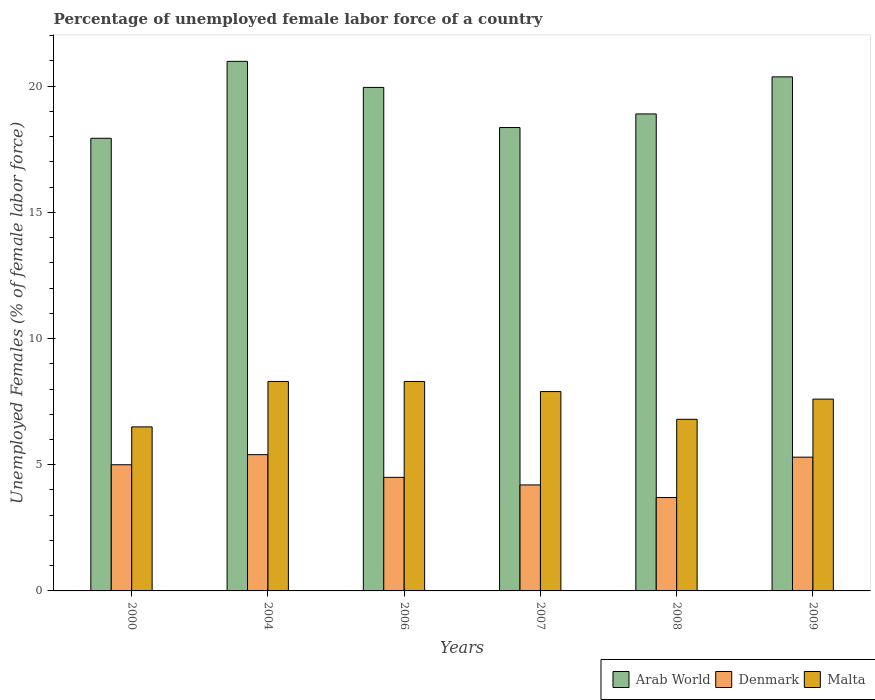How many bars are there on the 1st tick from the left?
Provide a succinct answer. 3. How many bars are there on the 5th tick from the right?
Your answer should be very brief. 3. In how many cases, is the number of bars for a given year not equal to the number of legend labels?
Offer a very short reply. 0. What is the percentage of unemployed female labor force in Denmark in 2008?
Provide a short and direct response. 3.7. Across all years, what is the maximum percentage of unemployed female labor force in Malta?
Your answer should be compact. 8.3. Across all years, what is the minimum percentage of unemployed female labor force in Arab World?
Your response must be concise. 17.94. What is the total percentage of unemployed female labor force in Malta in the graph?
Give a very brief answer. 45.4. What is the difference between the percentage of unemployed female labor force in Malta in 2000 and that in 2006?
Give a very brief answer. -1.8. What is the difference between the percentage of unemployed female labor force in Arab World in 2007 and the percentage of unemployed female labor force in Denmark in 2006?
Provide a succinct answer. 13.86. What is the average percentage of unemployed female labor force in Denmark per year?
Your response must be concise. 4.68. In the year 2006, what is the difference between the percentage of unemployed female labor force in Malta and percentage of unemployed female labor force in Denmark?
Provide a short and direct response. 3.8. What is the ratio of the percentage of unemployed female labor force in Denmark in 2007 to that in 2009?
Offer a very short reply. 0.79. Is the percentage of unemployed female labor force in Denmark in 2000 less than that in 2004?
Offer a terse response. Yes. Is the difference between the percentage of unemployed female labor force in Malta in 2007 and 2008 greater than the difference between the percentage of unemployed female labor force in Denmark in 2007 and 2008?
Make the answer very short. Yes. What is the difference between the highest and the lowest percentage of unemployed female labor force in Denmark?
Your answer should be very brief. 1.7. In how many years, is the percentage of unemployed female labor force in Denmark greater than the average percentage of unemployed female labor force in Denmark taken over all years?
Offer a very short reply. 3. What does the 3rd bar from the left in 2009 represents?
Offer a terse response. Malta. What does the 1st bar from the right in 2007 represents?
Your answer should be very brief. Malta. Is it the case that in every year, the sum of the percentage of unemployed female labor force in Malta and percentage of unemployed female labor force in Denmark is greater than the percentage of unemployed female labor force in Arab World?
Make the answer very short. No. How many bars are there?
Ensure brevity in your answer.  18. Are all the bars in the graph horizontal?
Your response must be concise. No. How many years are there in the graph?
Give a very brief answer. 6. Where does the legend appear in the graph?
Ensure brevity in your answer.  Bottom right. How are the legend labels stacked?
Keep it short and to the point. Horizontal. What is the title of the graph?
Ensure brevity in your answer.  Percentage of unemployed female labor force of a country. What is the label or title of the X-axis?
Your response must be concise. Years. What is the label or title of the Y-axis?
Ensure brevity in your answer.  Unemployed Females (% of female labor force). What is the Unemployed Females (% of female labor force) in Arab World in 2000?
Keep it short and to the point. 17.94. What is the Unemployed Females (% of female labor force) in Denmark in 2000?
Give a very brief answer. 5. What is the Unemployed Females (% of female labor force) in Malta in 2000?
Provide a succinct answer. 6.5. What is the Unemployed Females (% of female labor force) of Arab World in 2004?
Your response must be concise. 20.98. What is the Unemployed Females (% of female labor force) of Denmark in 2004?
Offer a very short reply. 5.4. What is the Unemployed Females (% of female labor force) in Malta in 2004?
Ensure brevity in your answer.  8.3. What is the Unemployed Females (% of female labor force) of Arab World in 2006?
Make the answer very short. 19.95. What is the Unemployed Females (% of female labor force) of Denmark in 2006?
Provide a short and direct response. 4.5. What is the Unemployed Females (% of female labor force) of Malta in 2006?
Your answer should be very brief. 8.3. What is the Unemployed Females (% of female labor force) in Arab World in 2007?
Give a very brief answer. 18.36. What is the Unemployed Females (% of female labor force) of Denmark in 2007?
Your answer should be very brief. 4.2. What is the Unemployed Females (% of female labor force) in Malta in 2007?
Your answer should be very brief. 7.9. What is the Unemployed Females (% of female labor force) of Arab World in 2008?
Make the answer very short. 18.9. What is the Unemployed Females (% of female labor force) in Denmark in 2008?
Your answer should be very brief. 3.7. What is the Unemployed Females (% of female labor force) in Malta in 2008?
Ensure brevity in your answer.  6.8. What is the Unemployed Females (% of female labor force) of Arab World in 2009?
Offer a very short reply. 20.37. What is the Unemployed Females (% of female labor force) of Denmark in 2009?
Provide a succinct answer. 5.3. What is the Unemployed Females (% of female labor force) in Malta in 2009?
Your answer should be very brief. 7.6. Across all years, what is the maximum Unemployed Females (% of female labor force) in Arab World?
Offer a very short reply. 20.98. Across all years, what is the maximum Unemployed Females (% of female labor force) of Denmark?
Give a very brief answer. 5.4. Across all years, what is the maximum Unemployed Females (% of female labor force) in Malta?
Provide a short and direct response. 8.3. Across all years, what is the minimum Unemployed Females (% of female labor force) in Arab World?
Give a very brief answer. 17.94. Across all years, what is the minimum Unemployed Females (% of female labor force) of Denmark?
Offer a very short reply. 3.7. Across all years, what is the minimum Unemployed Females (% of female labor force) of Malta?
Make the answer very short. 6.5. What is the total Unemployed Females (% of female labor force) in Arab World in the graph?
Provide a short and direct response. 116.5. What is the total Unemployed Females (% of female labor force) of Denmark in the graph?
Offer a terse response. 28.1. What is the total Unemployed Females (% of female labor force) in Malta in the graph?
Make the answer very short. 45.4. What is the difference between the Unemployed Females (% of female labor force) of Arab World in 2000 and that in 2004?
Offer a terse response. -3.05. What is the difference between the Unemployed Females (% of female labor force) in Denmark in 2000 and that in 2004?
Offer a terse response. -0.4. What is the difference between the Unemployed Females (% of female labor force) in Malta in 2000 and that in 2004?
Give a very brief answer. -1.8. What is the difference between the Unemployed Females (% of female labor force) in Arab World in 2000 and that in 2006?
Your response must be concise. -2.02. What is the difference between the Unemployed Females (% of female labor force) in Denmark in 2000 and that in 2006?
Make the answer very short. 0.5. What is the difference between the Unemployed Females (% of female labor force) in Arab World in 2000 and that in 2007?
Offer a very short reply. -0.43. What is the difference between the Unemployed Females (% of female labor force) in Denmark in 2000 and that in 2007?
Give a very brief answer. 0.8. What is the difference between the Unemployed Females (% of female labor force) in Arab World in 2000 and that in 2008?
Offer a very short reply. -0.96. What is the difference between the Unemployed Females (% of female labor force) of Denmark in 2000 and that in 2008?
Provide a short and direct response. 1.3. What is the difference between the Unemployed Females (% of female labor force) of Arab World in 2000 and that in 2009?
Your response must be concise. -2.43. What is the difference between the Unemployed Females (% of female labor force) of Malta in 2000 and that in 2009?
Provide a short and direct response. -1.1. What is the difference between the Unemployed Females (% of female labor force) in Arab World in 2004 and that in 2006?
Keep it short and to the point. 1.03. What is the difference between the Unemployed Females (% of female labor force) in Malta in 2004 and that in 2006?
Give a very brief answer. 0. What is the difference between the Unemployed Females (% of female labor force) of Arab World in 2004 and that in 2007?
Offer a very short reply. 2.62. What is the difference between the Unemployed Females (% of female labor force) of Denmark in 2004 and that in 2007?
Your answer should be very brief. 1.2. What is the difference between the Unemployed Females (% of female labor force) of Arab World in 2004 and that in 2008?
Ensure brevity in your answer.  2.08. What is the difference between the Unemployed Females (% of female labor force) in Denmark in 2004 and that in 2008?
Give a very brief answer. 1.7. What is the difference between the Unemployed Females (% of female labor force) of Malta in 2004 and that in 2008?
Your answer should be compact. 1.5. What is the difference between the Unemployed Females (% of female labor force) in Arab World in 2004 and that in 2009?
Your response must be concise. 0.61. What is the difference between the Unemployed Females (% of female labor force) of Arab World in 2006 and that in 2007?
Keep it short and to the point. 1.59. What is the difference between the Unemployed Females (% of female labor force) of Denmark in 2006 and that in 2007?
Give a very brief answer. 0.3. What is the difference between the Unemployed Females (% of female labor force) in Malta in 2006 and that in 2007?
Your answer should be compact. 0.4. What is the difference between the Unemployed Females (% of female labor force) in Arab World in 2006 and that in 2008?
Offer a terse response. 1.05. What is the difference between the Unemployed Females (% of female labor force) in Denmark in 2006 and that in 2008?
Make the answer very short. 0.8. What is the difference between the Unemployed Females (% of female labor force) in Malta in 2006 and that in 2008?
Ensure brevity in your answer.  1.5. What is the difference between the Unemployed Females (% of female labor force) of Arab World in 2006 and that in 2009?
Your answer should be very brief. -0.42. What is the difference between the Unemployed Females (% of female labor force) of Arab World in 2007 and that in 2008?
Offer a very short reply. -0.54. What is the difference between the Unemployed Females (% of female labor force) of Denmark in 2007 and that in 2008?
Your answer should be compact. 0.5. What is the difference between the Unemployed Females (% of female labor force) in Malta in 2007 and that in 2008?
Your answer should be compact. 1.1. What is the difference between the Unemployed Females (% of female labor force) of Arab World in 2007 and that in 2009?
Provide a succinct answer. -2.01. What is the difference between the Unemployed Females (% of female labor force) in Denmark in 2007 and that in 2009?
Provide a short and direct response. -1.1. What is the difference between the Unemployed Females (% of female labor force) in Malta in 2007 and that in 2009?
Give a very brief answer. 0.3. What is the difference between the Unemployed Females (% of female labor force) in Arab World in 2008 and that in 2009?
Ensure brevity in your answer.  -1.47. What is the difference between the Unemployed Females (% of female labor force) of Malta in 2008 and that in 2009?
Offer a terse response. -0.8. What is the difference between the Unemployed Females (% of female labor force) in Arab World in 2000 and the Unemployed Females (% of female labor force) in Denmark in 2004?
Your response must be concise. 12.54. What is the difference between the Unemployed Females (% of female labor force) in Arab World in 2000 and the Unemployed Females (% of female labor force) in Malta in 2004?
Provide a short and direct response. 9.64. What is the difference between the Unemployed Females (% of female labor force) in Denmark in 2000 and the Unemployed Females (% of female labor force) in Malta in 2004?
Provide a succinct answer. -3.3. What is the difference between the Unemployed Females (% of female labor force) in Arab World in 2000 and the Unemployed Females (% of female labor force) in Denmark in 2006?
Your answer should be very brief. 13.44. What is the difference between the Unemployed Females (% of female labor force) in Arab World in 2000 and the Unemployed Females (% of female labor force) in Malta in 2006?
Give a very brief answer. 9.64. What is the difference between the Unemployed Females (% of female labor force) in Arab World in 2000 and the Unemployed Females (% of female labor force) in Denmark in 2007?
Provide a succinct answer. 13.74. What is the difference between the Unemployed Females (% of female labor force) in Arab World in 2000 and the Unemployed Females (% of female labor force) in Malta in 2007?
Offer a terse response. 10.04. What is the difference between the Unemployed Females (% of female labor force) in Arab World in 2000 and the Unemployed Females (% of female labor force) in Denmark in 2008?
Your answer should be compact. 14.24. What is the difference between the Unemployed Females (% of female labor force) in Arab World in 2000 and the Unemployed Females (% of female labor force) in Malta in 2008?
Offer a very short reply. 11.14. What is the difference between the Unemployed Females (% of female labor force) of Denmark in 2000 and the Unemployed Females (% of female labor force) of Malta in 2008?
Offer a terse response. -1.8. What is the difference between the Unemployed Females (% of female labor force) in Arab World in 2000 and the Unemployed Females (% of female labor force) in Denmark in 2009?
Provide a short and direct response. 12.64. What is the difference between the Unemployed Females (% of female labor force) in Arab World in 2000 and the Unemployed Females (% of female labor force) in Malta in 2009?
Your answer should be compact. 10.34. What is the difference between the Unemployed Females (% of female labor force) of Arab World in 2004 and the Unemployed Females (% of female labor force) of Denmark in 2006?
Make the answer very short. 16.48. What is the difference between the Unemployed Females (% of female labor force) of Arab World in 2004 and the Unemployed Females (% of female labor force) of Malta in 2006?
Ensure brevity in your answer.  12.68. What is the difference between the Unemployed Females (% of female labor force) in Denmark in 2004 and the Unemployed Females (% of female labor force) in Malta in 2006?
Your response must be concise. -2.9. What is the difference between the Unemployed Females (% of female labor force) in Arab World in 2004 and the Unemployed Females (% of female labor force) in Denmark in 2007?
Provide a succinct answer. 16.78. What is the difference between the Unemployed Females (% of female labor force) in Arab World in 2004 and the Unemployed Females (% of female labor force) in Malta in 2007?
Offer a very short reply. 13.08. What is the difference between the Unemployed Females (% of female labor force) in Denmark in 2004 and the Unemployed Females (% of female labor force) in Malta in 2007?
Offer a terse response. -2.5. What is the difference between the Unemployed Females (% of female labor force) of Arab World in 2004 and the Unemployed Females (% of female labor force) of Denmark in 2008?
Provide a short and direct response. 17.28. What is the difference between the Unemployed Females (% of female labor force) in Arab World in 2004 and the Unemployed Females (% of female labor force) in Malta in 2008?
Your response must be concise. 14.18. What is the difference between the Unemployed Females (% of female labor force) in Denmark in 2004 and the Unemployed Females (% of female labor force) in Malta in 2008?
Make the answer very short. -1.4. What is the difference between the Unemployed Females (% of female labor force) in Arab World in 2004 and the Unemployed Females (% of female labor force) in Denmark in 2009?
Offer a terse response. 15.68. What is the difference between the Unemployed Females (% of female labor force) of Arab World in 2004 and the Unemployed Females (% of female labor force) of Malta in 2009?
Offer a very short reply. 13.38. What is the difference between the Unemployed Females (% of female labor force) of Arab World in 2006 and the Unemployed Females (% of female labor force) of Denmark in 2007?
Give a very brief answer. 15.75. What is the difference between the Unemployed Females (% of female labor force) in Arab World in 2006 and the Unemployed Females (% of female labor force) in Malta in 2007?
Your response must be concise. 12.05. What is the difference between the Unemployed Females (% of female labor force) of Denmark in 2006 and the Unemployed Females (% of female labor force) of Malta in 2007?
Provide a succinct answer. -3.4. What is the difference between the Unemployed Females (% of female labor force) in Arab World in 2006 and the Unemployed Females (% of female labor force) in Denmark in 2008?
Provide a succinct answer. 16.25. What is the difference between the Unemployed Females (% of female labor force) of Arab World in 2006 and the Unemployed Females (% of female labor force) of Malta in 2008?
Offer a very short reply. 13.15. What is the difference between the Unemployed Females (% of female labor force) of Denmark in 2006 and the Unemployed Females (% of female labor force) of Malta in 2008?
Give a very brief answer. -2.3. What is the difference between the Unemployed Females (% of female labor force) in Arab World in 2006 and the Unemployed Females (% of female labor force) in Denmark in 2009?
Offer a terse response. 14.65. What is the difference between the Unemployed Females (% of female labor force) of Arab World in 2006 and the Unemployed Females (% of female labor force) of Malta in 2009?
Give a very brief answer. 12.35. What is the difference between the Unemployed Females (% of female labor force) in Arab World in 2007 and the Unemployed Females (% of female labor force) in Denmark in 2008?
Your answer should be very brief. 14.66. What is the difference between the Unemployed Females (% of female labor force) in Arab World in 2007 and the Unemployed Females (% of female labor force) in Malta in 2008?
Make the answer very short. 11.56. What is the difference between the Unemployed Females (% of female labor force) of Denmark in 2007 and the Unemployed Females (% of female labor force) of Malta in 2008?
Ensure brevity in your answer.  -2.6. What is the difference between the Unemployed Females (% of female labor force) of Arab World in 2007 and the Unemployed Females (% of female labor force) of Denmark in 2009?
Ensure brevity in your answer.  13.06. What is the difference between the Unemployed Females (% of female labor force) in Arab World in 2007 and the Unemployed Females (% of female labor force) in Malta in 2009?
Keep it short and to the point. 10.76. What is the difference between the Unemployed Females (% of female labor force) in Denmark in 2007 and the Unemployed Females (% of female labor force) in Malta in 2009?
Provide a succinct answer. -3.4. What is the difference between the Unemployed Females (% of female labor force) of Arab World in 2008 and the Unemployed Females (% of female labor force) of Denmark in 2009?
Keep it short and to the point. 13.6. What is the difference between the Unemployed Females (% of female labor force) in Arab World in 2008 and the Unemployed Females (% of female labor force) in Malta in 2009?
Offer a very short reply. 11.3. What is the difference between the Unemployed Females (% of female labor force) of Denmark in 2008 and the Unemployed Females (% of female labor force) of Malta in 2009?
Offer a very short reply. -3.9. What is the average Unemployed Females (% of female labor force) in Arab World per year?
Give a very brief answer. 19.42. What is the average Unemployed Females (% of female labor force) in Denmark per year?
Keep it short and to the point. 4.68. What is the average Unemployed Females (% of female labor force) in Malta per year?
Provide a short and direct response. 7.57. In the year 2000, what is the difference between the Unemployed Females (% of female labor force) of Arab World and Unemployed Females (% of female labor force) of Denmark?
Offer a terse response. 12.94. In the year 2000, what is the difference between the Unemployed Females (% of female labor force) of Arab World and Unemployed Females (% of female labor force) of Malta?
Give a very brief answer. 11.44. In the year 2000, what is the difference between the Unemployed Females (% of female labor force) of Denmark and Unemployed Females (% of female labor force) of Malta?
Keep it short and to the point. -1.5. In the year 2004, what is the difference between the Unemployed Females (% of female labor force) in Arab World and Unemployed Females (% of female labor force) in Denmark?
Your answer should be very brief. 15.58. In the year 2004, what is the difference between the Unemployed Females (% of female labor force) in Arab World and Unemployed Females (% of female labor force) in Malta?
Offer a terse response. 12.68. In the year 2004, what is the difference between the Unemployed Females (% of female labor force) in Denmark and Unemployed Females (% of female labor force) in Malta?
Your answer should be very brief. -2.9. In the year 2006, what is the difference between the Unemployed Females (% of female labor force) of Arab World and Unemployed Females (% of female labor force) of Denmark?
Make the answer very short. 15.45. In the year 2006, what is the difference between the Unemployed Females (% of female labor force) in Arab World and Unemployed Females (% of female labor force) in Malta?
Provide a short and direct response. 11.65. In the year 2007, what is the difference between the Unemployed Females (% of female labor force) in Arab World and Unemployed Females (% of female labor force) in Denmark?
Keep it short and to the point. 14.16. In the year 2007, what is the difference between the Unemployed Females (% of female labor force) in Arab World and Unemployed Females (% of female labor force) in Malta?
Give a very brief answer. 10.46. In the year 2008, what is the difference between the Unemployed Females (% of female labor force) in Arab World and Unemployed Females (% of female labor force) in Denmark?
Give a very brief answer. 15.2. In the year 2008, what is the difference between the Unemployed Females (% of female labor force) in Arab World and Unemployed Females (% of female labor force) in Malta?
Give a very brief answer. 12.1. In the year 2009, what is the difference between the Unemployed Females (% of female labor force) in Arab World and Unemployed Females (% of female labor force) in Denmark?
Provide a short and direct response. 15.07. In the year 2009, what is the difference between the Unemployed Females (% of female labor force) in Arab World and Unemployed Females (% of female labor force) in Malta?
Your response must be concise. 12.77. What is the ratio of the Unemployed Females (% of female labor force) in Arab World in 2000 to that in 2004?
Ensure brevity in your answer.  0.85. What is the ratio of the Unemployed Females (% of female labor force) of Denmark in 2000 to that in 2004?
Your response must be concise. 0.93. What is the ratio of the Unemployed Females (% of female labor force) of Malta in 2000 to that in 2004?
Keep it short and to the point. 0.78. What is the ratio of the Unemployed Females (% of female labor force) of Arab World in 2000 to that in 2006?
Offer a very short reply. 0.9. What is the ratio of the Unemployed Females (% of female labor force) of Denmark in 2000 to that in 2006?
Provide a short and direct response. 1.11. What is the ratio of the Unemployed Females (% of female labor force) in Malta in 2000 to that in 2006?
Keep it short and to the point. 0.78. What is the ratio of the Unemployed Females (% of female labor force) in Arab World in 2000 to that in 2007?
Ensure brevity in your answer.  0.98. What is the ratio of the Unemployed Females (% of female labor force) of Denmark in 2000 to that in 2007?
Offer a very short reply. 1.19. What is the ratio of the Unemployed Females (% of female labor force) in Malta in 2000 to that in 2007?
Provide a short and direct response. 0.82. What is the ratio of the Unemployed Females (% of female labor force) of Arab World in 2000 to that in 2008?
Offer a very short reply. 0.95. What is the ratio of the Unemployed Females (% of female labor force) in Denmark in 2000 to that in 2008?
Offer a terse response. 1.35. What is the ratio of the Unemployed Females (% of female labor force) in Malta in 2000 to that in 2008?
Give a very brief answer. 0.96. What is the ratio of the Unemployed Females (% of female labor force) in Arab World in 2000 to that in 2009?
Ensure brevity in your answer.  0.88. What is the ratio of the Unemployed Females (% of female labor force) in Denmark in 2000 to that in 2009?
Your response must be concise. 0.94. What is the ratio of the Unemployed Females (% of female labor force) in Malta in 2000 to that in 2009?
Offer a very short reply. 0.86. What is the ratio of the Unemployed Females (% of female labor force) in Arab World in 2004 to that in 2006?
Provide a short and direct response. 1.05. What is the ratio of the Unemployed Females (% of female labor force) in Malta in 2004 to that in 2006?
Your answer should be very brief. 1. What is the ratio of the Unemployed Females (% of female labor force) of Arab World in 2004 to that in 2007?
Your answer should be compact. 1.14. What is the ratio of the Unemployed Females (% of female labor force) of Malta in 2004 to that in 2007?
Offer a very short reply. 1.05. What is the ratio of the Unemployed Females (% of female labor force) in Arab World in 2004 to that in 2008?
Offer a terse response. 1.11. What is the ratio of the Unemployed Females (% of female labor force) in Denmark in 2004 to that in 2008?
Provide a succinct answer. 1.46. What is the ratio of the Unemployed Females (% of female labor force) in Malta in 2004 to that in 2008?
Offer a terse response. 1.22. What is the ratio of the Unemployed Females (% of female labor force) in Arab World in 2004 to that in 2009?
Your answer should be compact. 1.03. What is the ratio of the Unemployed Females (% of female labor force) of Denmark in 2004 to that in 2009?
Keep it short and to the point. 1.02. What is the ratio of the Unemployed Females (% of female labor force) of Malta in 2004 to that in 2009?
Provide a succinct answer. 1.09. What is the ratio of the Unemployed Females (% of female labor force) of Arab World in 2006 to that in 2007?
Provide a short and direct response. 1.09. What is the ratio of the Unemployed Females (% of female labor force) in Denmark in 2006 to that in 2007?
Keep it short and to the point. 1.07. What is the ratio of the Unemployed Females (% of female labor force) in Malta in 2006 to that in 2007?
Offer a terse response. 1.05. What is the ratio of the Unemployed Females (% of female labor force) in Arab World in 2006 to that in 2008?
Your answer should be very brief. 1.06. What is the ratio of the Unemployed Females (% of female labor force) in Denmark in 2006 to that in 2008?
Make the answer very short. 1.22. What is the ratio of the Unemployed Females (% of female labor force) in Malta in 2006 to that in 2008?
Offer a very short reply. 1.22. What is the ratio of the Unemployed Females (% of female labor force) in Arab World in 2006 to that in 2009?
Give a very brief answer. 0.98. What is the ratio of the Unemployed Females (% of female labor force) in Denmark in 2006 to that in 2009?
Ensure brevity in your answer.  0.85. What is the ratio of the Unemployed Females (% of female labor force) of Malta in 2006 to that in 2009?
Give a very brief answer. 1.09. What is the ratio of the Unemployed Females (% of female labor force) of Arab World in 2007 to that in 2008?
Your answer should be compact. 0.97. What is the ratio of the Unemployed Females (% of female labor force) of Denmark in 2007 to that in 2008?
Your response must be concise. 1.14. What is the ratio of the Unemployed Females (% of female labor force) in Malta in 2007 to that in 2008?
Ensure brevity in your answer.  1.16. What is the ratio of the Unemployed Females (% of female labor force) in Arab World in 2007 to that in 2009?
Give a very brief answer. 0.9. What is the ratio of the Unemployed Females (% of female labor force) of Denmark in 2007 to that in 2009?
Provide a succinct answer. 0.79. What is the ratio of the Unemployed Females (% of female labor force) in Malta in 2007 to that in 2009?
Provide a succinct answer. 1.04. What is the ratio of the Unemployed Females (% of female labor force) of Arab World in 2008 to that in 2009?
Provide a short and direct response. 0.93. What is the ratio of the Unemployed Females (% of female labor force) in Denmark in 2008 to that in 2009?
Your answer should be compact. 0.7. What is the ratio of the Unemployed Females (% of female labor force) in Malta in 2008 to that in 2009?
Your response must be concise. 0.89. What is the difference between the highest and the second highest Unemployed Females (% of female labor force) in Arab World?
Your response must be concise. 0.61. What is the difference between the highest and the second highest Unemployed Females (% of female labor force) in Denmark?
Make the answer very short. 0.1. What is the difference between the highest and the lowest Unemployed Females (% of female labor force) in Arab World?
Offer a very short reply. 3.05. 